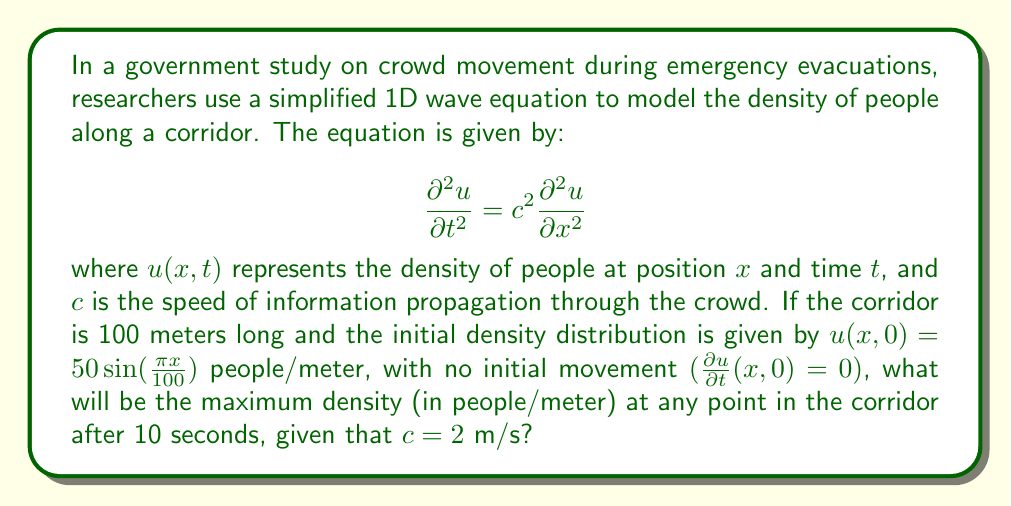Could you help me with this problem? Let's approach this step-by-step:

1) The general solution to the 1D wave equation with the given initial conditions is:

   $$u(x,t) = A \cos(\omega t) \sin(kx)$$

   where $A$ is the amplitude, $\omega$ is the angular frequency, and $k$ is the wave number.

2) From the initial condition $u(x,0) = 50 \sin(\frac{\pi x}{100})$, we can deduce:
   
   $A = 50$ and $k = \frac{\pi}{100}$

3) The relationship between $\omega$, $k$, and $c$ is:

   $$\omega = ck = \frac{2\pi}{100} = \frac{\pi}{50}$$

4) Therefore, our solution becomes:

   $$u(x,t) = 50 \cos(\frac{\pi t}{50}) \sin(\frac{\pi x}{100})$$

5) To find the maximum density at any point after 10 seconds, we need to maximize this function with respect to $x$ when $t = 10$:

   $$u(x,10) = 50 \cos(\frac{\pi 10}{50}) \sin(\frac{\pi x}{100})$$

6) The maximum value of sine is 1, so the maximum density will occur where $\sin(\frac{\pi x}{100}) = 1$, and its value will be:

   $$u_{max} = 50 |\cos(\frac{\pi 10}{50})| = 50 |\cos(\frac{\pi}{5})| \approx 45.1$$

Therefore, the maximum density at any point in the corridor after 10 seconds will be approximately 45.1 people/meter.
Answer: 45.1 people/meter 